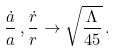<formula> <loc_0><loc_0><loc_500><loc_500>\frac { \dot { a } } { a } \, , \frac { \dot { r } } { r } \rightarrow \sqrt { \frac { \Lambda } { 4 5 } } \, .</formula> 